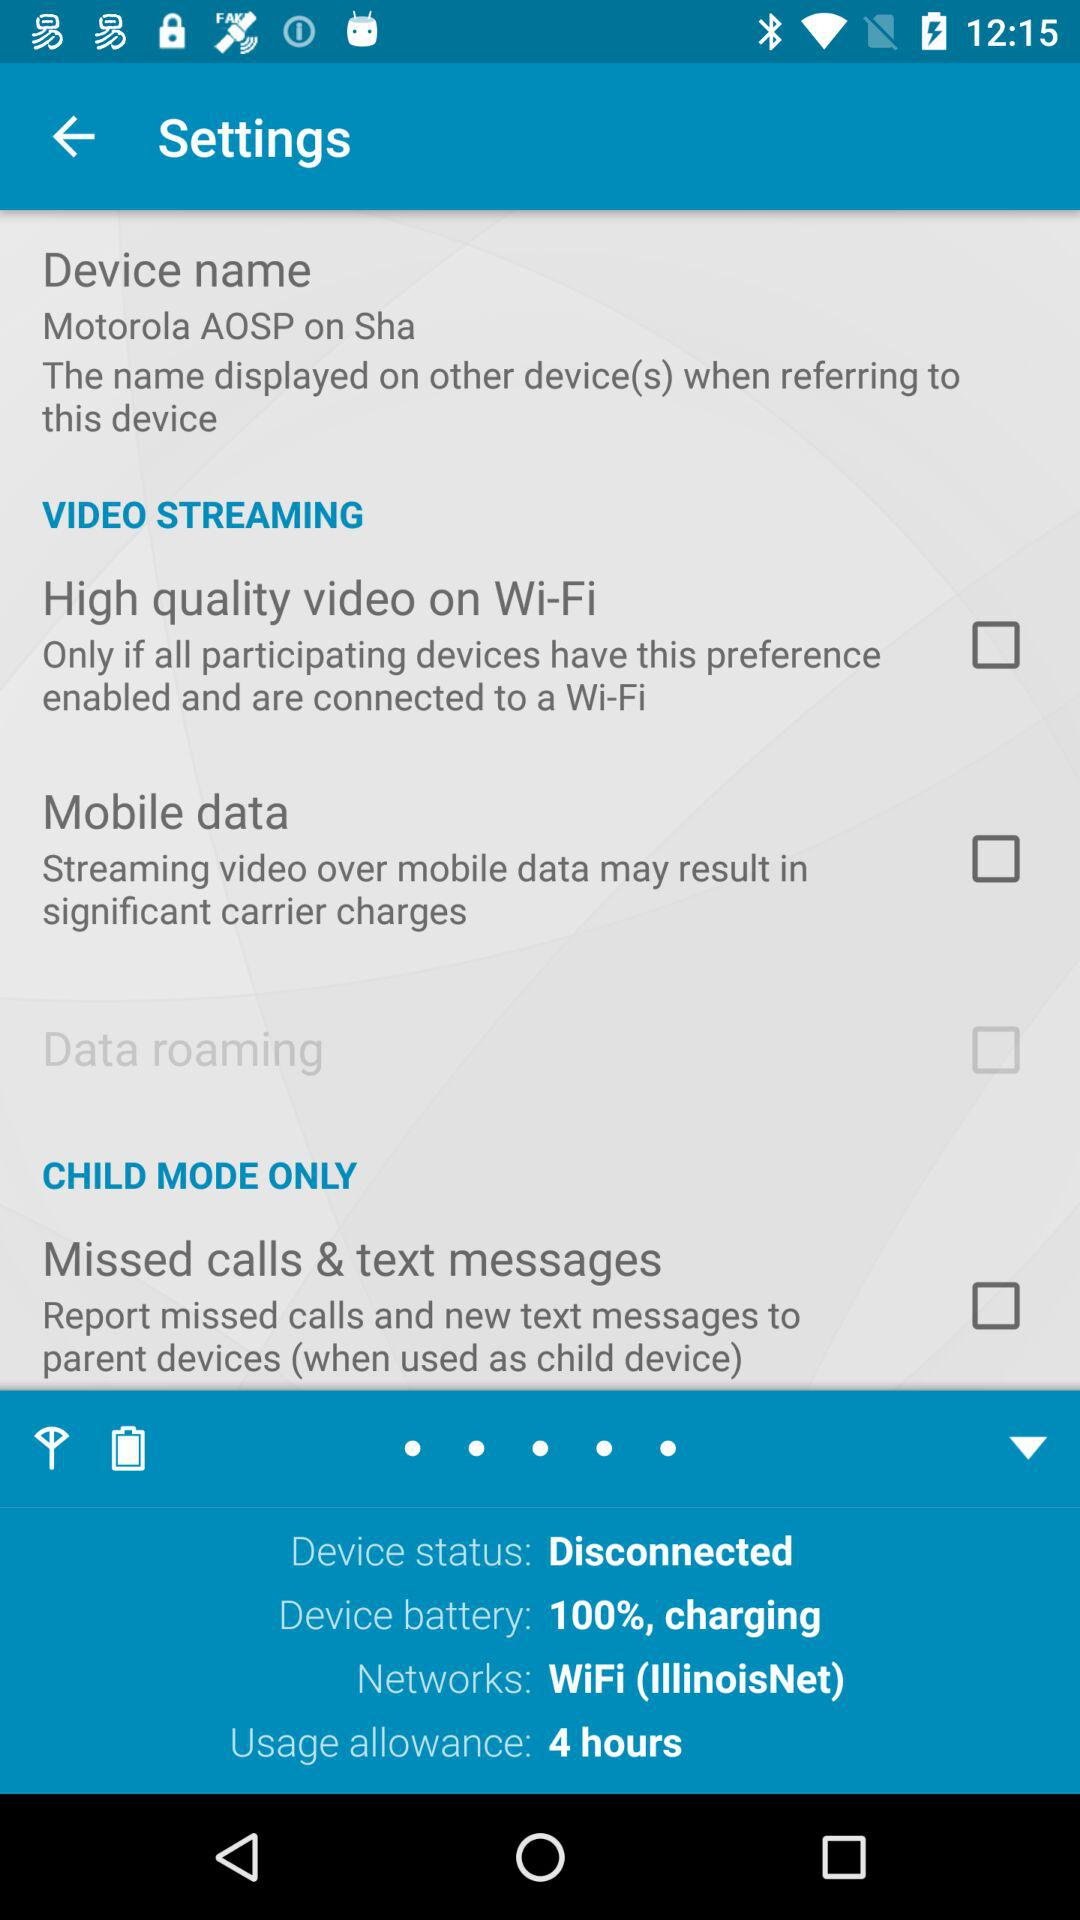How much battery is charged for this device? This device's battery is charged to 100%. 